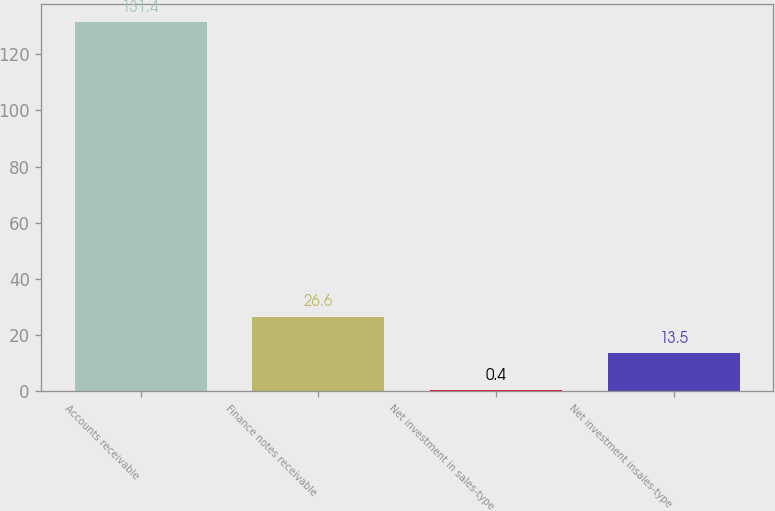Convert chart to OTSL. <chart><loc_0><loc_0><loc_500><loc_500><bar_chart><fcel>Accounts receivable<fcel>Finance notes receivable<fcel>Net investment in sales-type<fcel>Net investment insales-type<nl><fcel>131.4<fcel>26.6<fcel>0.4<fcel>13.5<nl></chart> 